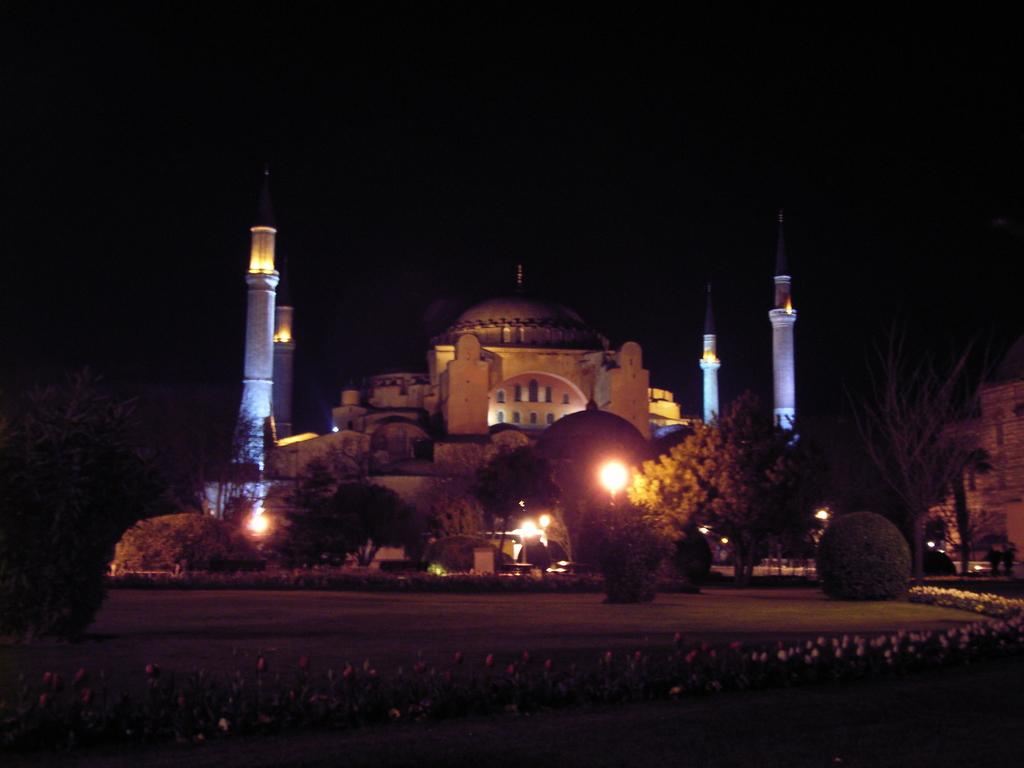What types of vegetation are present at the bottom of the image? There are plants and flowers at the bottom of the image. What can be seen in the middle of the image? There are trees and poles in the middle of the image, as well as a building. Can you describe the building in the image? The building is located in the middle of the image. How many cacti can be seen in the image? There are no cacti present in the image. What type of detail can be seen on the poles in the image? The provided facts do not mention any specific details on the poles, so we cannot answer this question definitively. 